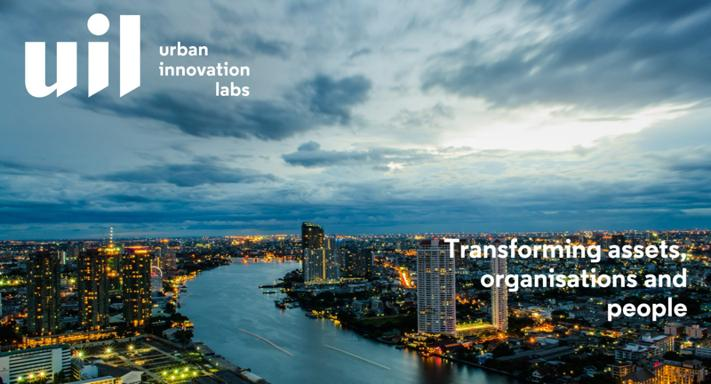What is the purpose of UIL Urban Innovation Labs? The core purpose of UIL Urban Innovation Labs is to spearhead urban transformation by innovatively tackling the improvement of assets, organizations, and people. They strive to enhance infrastructure, promote sustainable development, and elevate the overall quality of life in urban settings, thereby shaping the future of our metropolitan areas. 